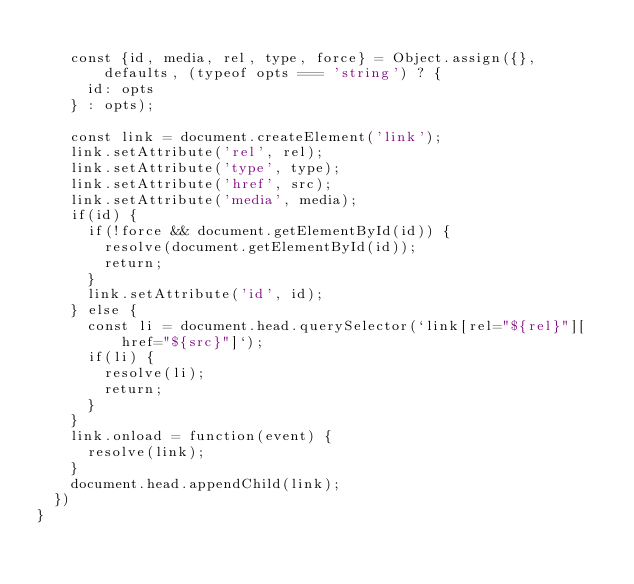<code> <loc_0><loc_0><loc_500><loc_500><_JavaScript_>
    const {id, media, rel, type, force} = Object.assign({}, defaults, (typeof opts === 'string') ? {
      id: opts
    } : opts);

    const link = document.createElement('link');
    link.setAttribute('rel', rel);
    link.setAttribute('type', type);
    link.setAttribute('href', src);
    link.setAttribute('media', media);
    if(id) {
      if(!force && document.getElementById(id)) {
        resolve(document.getElementById(id));
        return;
      }
      link.setAttribute('id', id);
    } else {
      const li = document.head.querySelector(`link[rel="${rel}"][href="${src}"]`);
      if(li) {
        resolve(li);
        return;
      }
    }
    link.onload = function(event) {
      resolve(link);
    }
    document.head.appendChild(link);
  })
}
</code> 